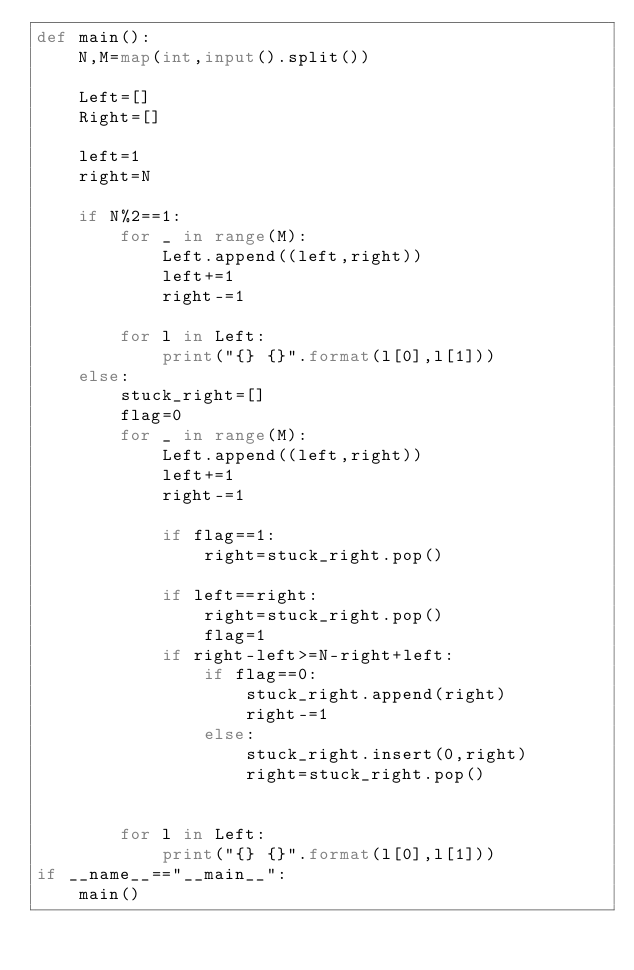<code> <loc_0><loc_0><loc_500><loc_500><_Python_>def main():
    N,M=map(int,input().split())

    Left=[]
    Right=[]

    left=1
    right=N

    if N%2==1:
        for _ in range(M):
            Left.append((left,right))
            left+=1
            right-=1

        for l in Left:
            print("{} {}".format(l[0],l[1]))
    else:
        stuck_right=[]
        flag=0
        for _ in range(M):
            Left.append((left,right))
            left+=1
            right-=1

            if flag==1:
                right=stuck_right.pop()

            if left==right:
                right=stuck_right.pop()
                flag=1
            if right-left>=N-right+left:
                if flag==0:
                    stuck_right.append(right)
                    right-=1
                else:
                    stuck_right.insert(0,right)
                    right=stuck_right.pop()


        for l in Left:
            print("{} {}".format(l[0],l[1]))
if __name__=="__main__":
    main()</code> 